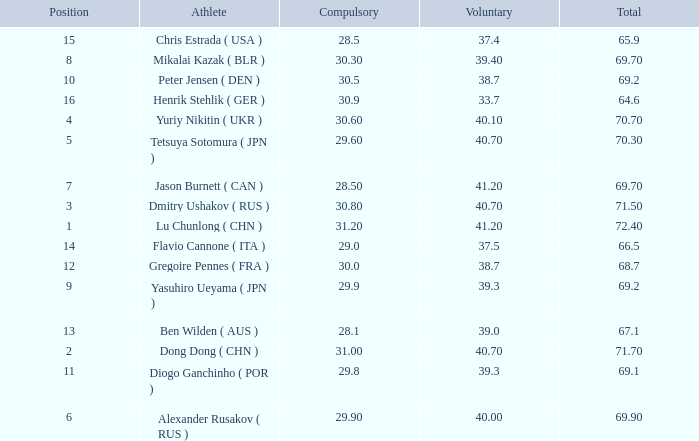What's the total compulsory when the total is more than 69.2 and the voluntary is 38.7? 0.0. 